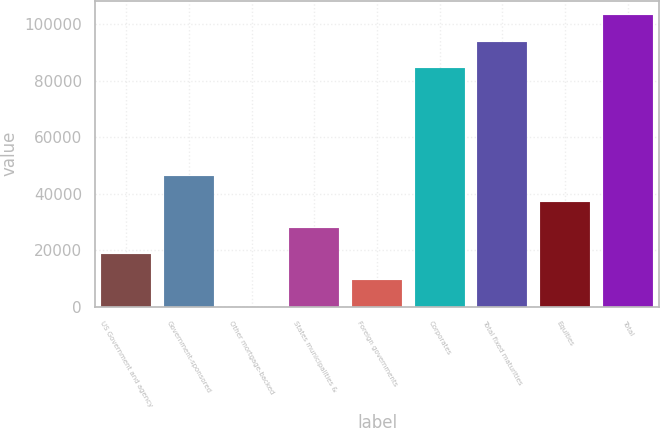Convert chart to OTSL. <chart><loc_0><loc_0><loc_500><loc_500><bar_chart><fcel>US Government and agency<fcel>Government-sponsored<fcel>Other mortgage-backed<fcel>States municipalities &<fcel>Foreign governments<fcel>Corporates<fcel>Total fixed maturities<fcel>Equities<fcel>Total<nl><fcel>18581.8<fcel>46449.6<fcel>3.22<fcel>27871.1<fcel>9292.5<fcel>84578<fcel>93867.3<fcel>37160.3<fcel>103157<nl></chart> 